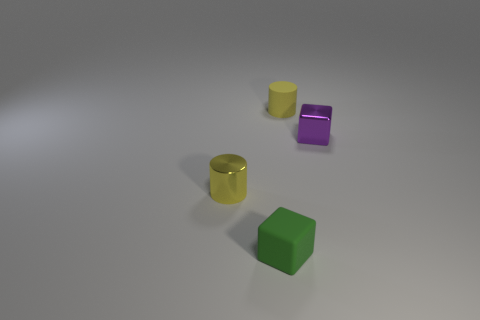Add 1 gray cubes. How many objects exist? 5 Subtract 1 cylinders. How many cylinders are left? 1 Subtract all big green shiny blocks. Subtract all yellow metal things. How many objects are left? 3 Add 2 small purple objects. How many small purple objects are left? 3 Add 3 tiny purple cubes. How many tiny purple cubes exist? 4 Subtract 0 cyan cylinders. How many objects are left? 4 Subtract all purple cylinders. Subtract all cyan balls. How many cylinders are left? 2 Subtract all brown cylinders. How many purple blocks are left? 1 